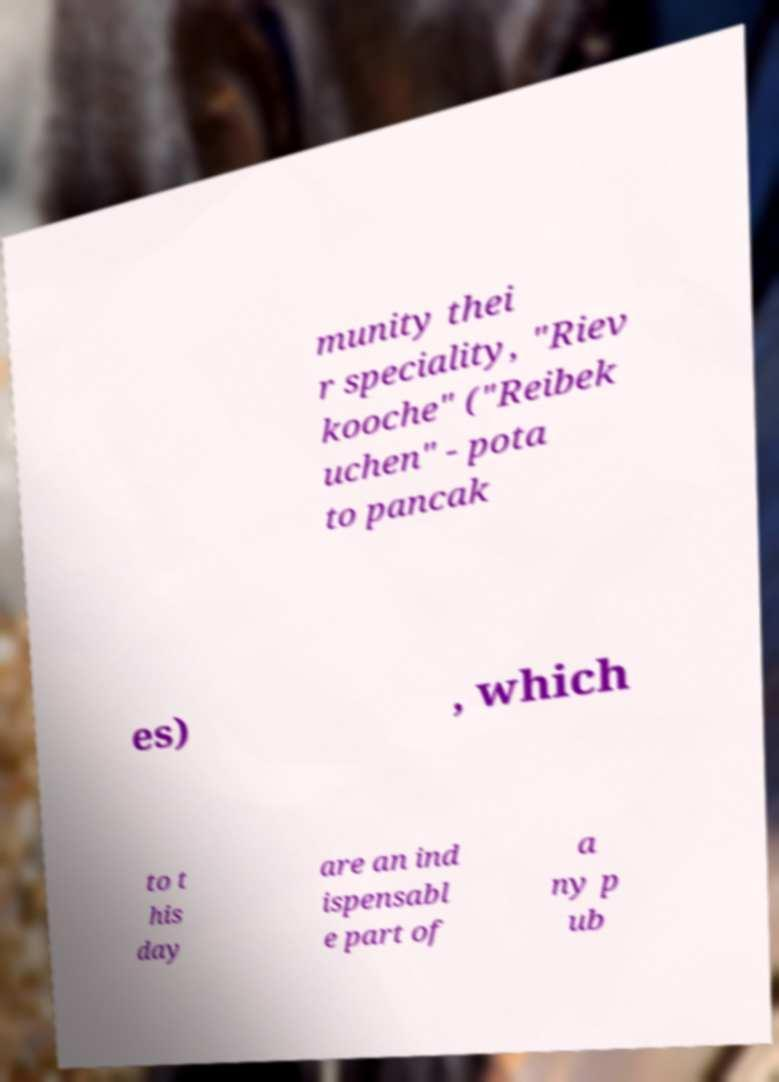Can you read and provide the text displayed in the image?This photo seems to have some interesting text. Can you extract and type it out for me? munity thei r speciality, "Riev kooche" ("Reibek uchen" - pota to pancak es) , which to t his day are an ind ispensabl e part of a ny p ub 